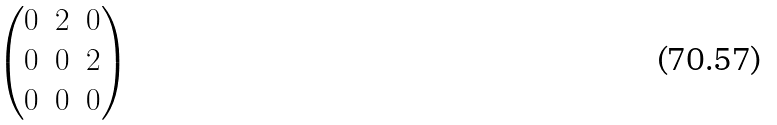Convert formula to latex. <formula><loc_0><loc_0><loc_500><loc_500>\begin{pmatrix} 0 & 2 & 0 \\ 0 & 0 & 2 \\ 0 & 0 & 0 \end{pmatrix}</formula> 